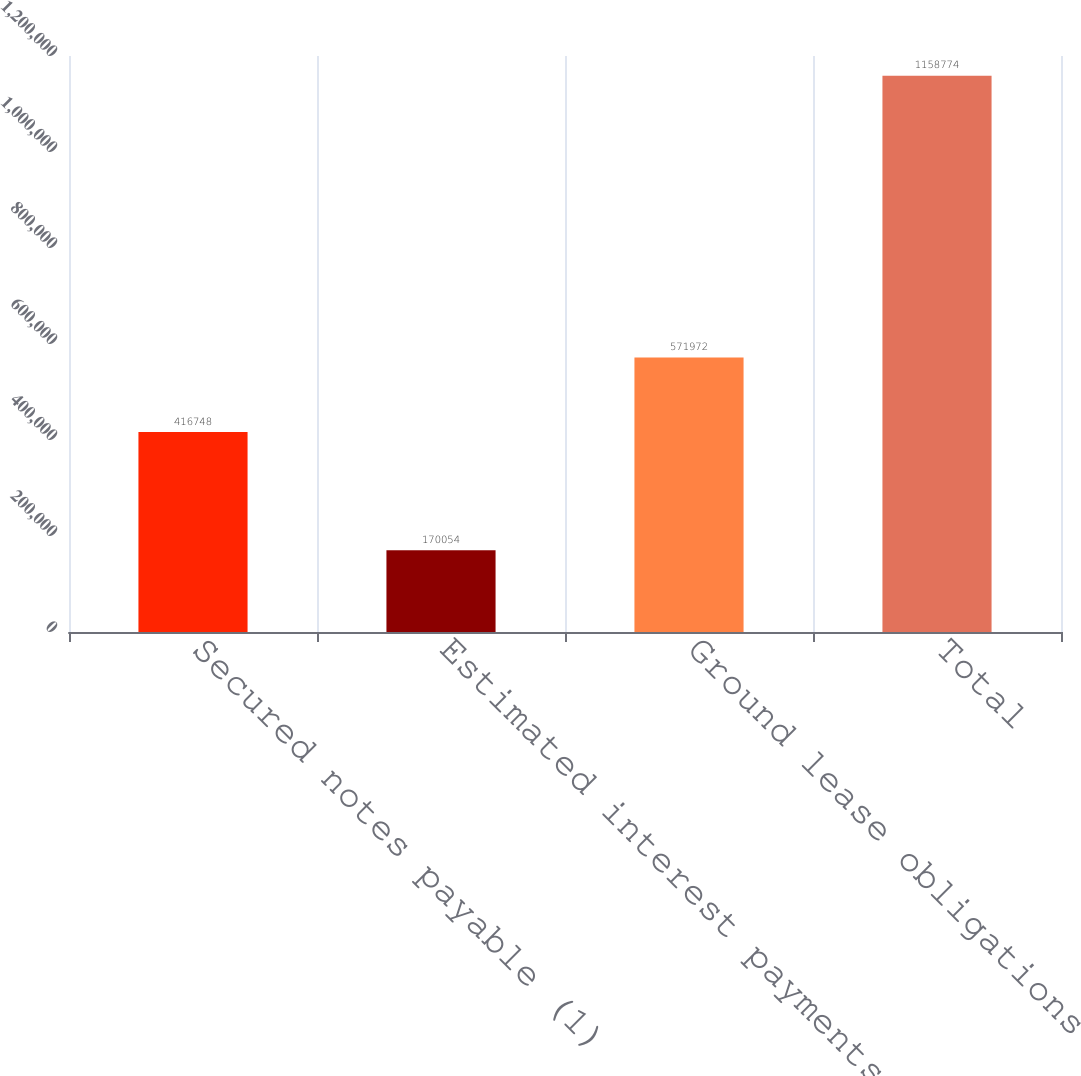<chart> <loc_0><loc_0><loc_500><loc_500><bar_chart><fcel>Secured notes payable (1)<fcel>Estimated interest payments<fcel>Ground lease obligations<fcel>Total<nl><fcel>416748<fcel>170054<fcel>571972<fcel>1.15877e+06<nl></chart> 